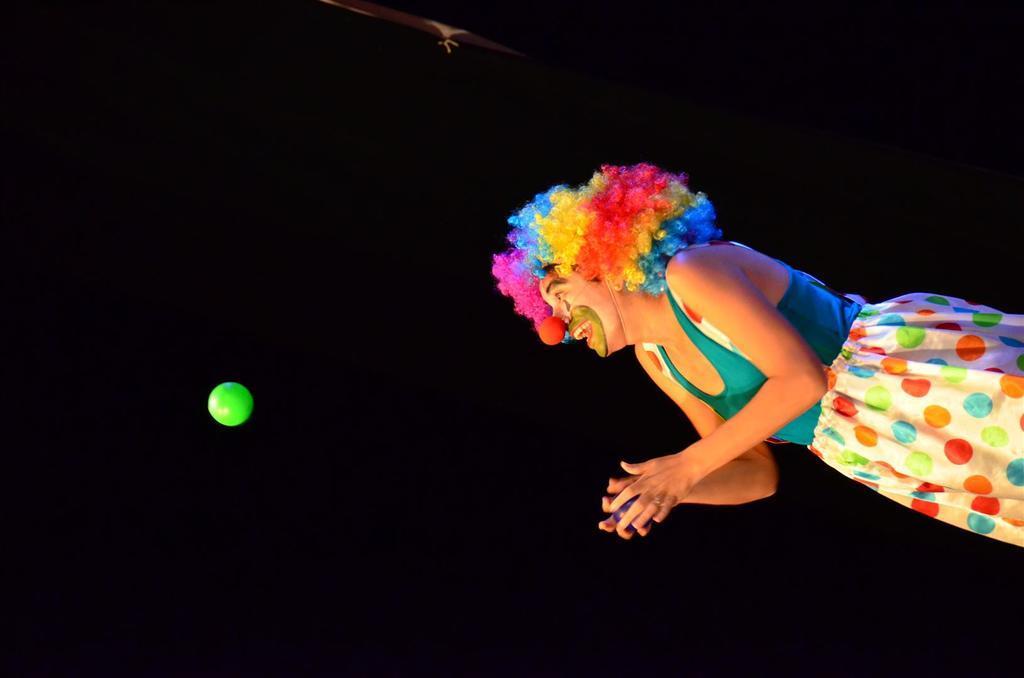How would you summarize this image in a sentence or two? In this image there is a person holding a ball in his hand, in front of the person in the air there is another ball. 